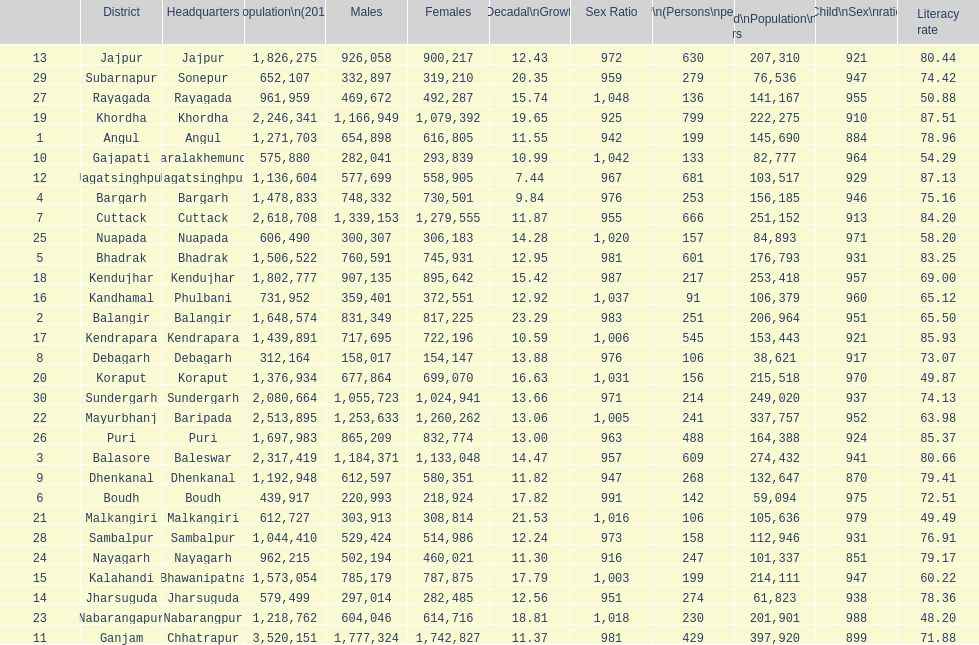Which district has a higher population, angul or cuttack? Cuttack. 